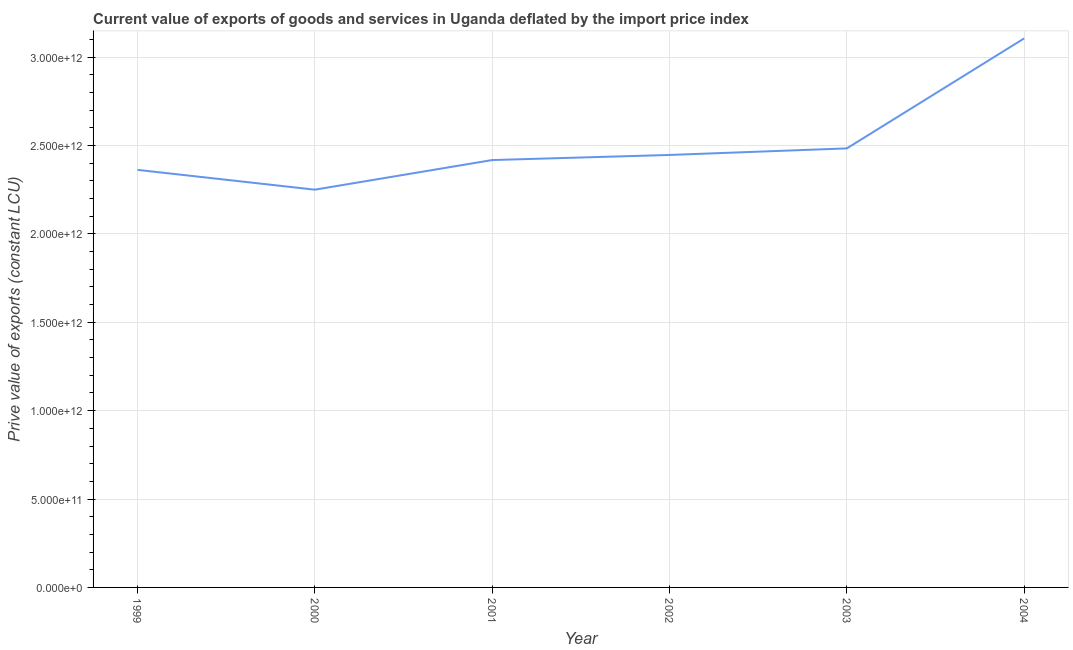What is the price value of exports in 2002?
Provide a short and direct response. 2.45e+12. Across all years, what is the maximum price value of exports?
Ensure brevity in your answer.  3.11e+12. Across all years, what is the minimum price value of exports?
Offer a terse response. 2.25e+12. In which year was the price value of exports maximum?
Your answer should be very brief. 2004. In which year was the price value of exports minimum?
Make the answer very short. 2000. What is the sum of the price value of exports?
Provide a short and direct response. 1.51e+13. What is the difference between the price value of exports in 2000 and 2001?
Offer a terse response. -1.68e+11. What is the average price value of exports per year?
Provide a succinct answer. 2.51e+12. What is the median price value of exports?
Your answer should be very brief. 2.43e+12. What is the ratio of the price value of exports in 1999 to that in 2002?
Your answer should be compact. 0.97. Is the difference between the price value of exports in 2002 and 2003 greater than the difference between any two years?
Your answer should be very brief. No. What is the difference between the highest and the second highest price value of exports?
Make the answer very short. 6.22e+11. Is the sum of the price value of exports in 1999 and 2000 greater than the maximum price value of exports across all years?
Your answer should be compact. Yes. What is the difference between the highest and the lowest price value of exports?
Make the answer very short. 8.56e+11. In how many years, is the price value of exports greater than the average price value of exports taken over all years?
Keep it short and to the point. 1. What is the difference between two consecutive major ticks on the Y-axis?
Provide a short and direct response. 5.00e+11. Does the graph contain grids?
Ensure brevity in your answer.  Yes. What is the title of the graph?
Provide a succinct answer. Current value of exports of goods and services in Uganda deflated by the import price index. What is the label or title of the X-axis?
Give a very brief answer. Year. What is the label or title of the Y-axis?
Your answer should be very brief. Prive value of exports (constant LCU). What is the Prive value of exports (constant LCU) of 1999?
Your answer should be very brief. 2.36e+12. What is the Prive value of exports (constant LCU) of 2000?
Provide a short and direct response. 2.25e+12. What is the Prive value of exports (constant LCU) of 2001?
Give a very brief answer. 2.42e+12. What is the Prive value of exports (constant LCU) of 2002?
Offer a terse response. 2.45e+12. What is the Prive value of exports (constant LCU) of 2003?
Your response must be concise. 2.48e+12. What is the Prive value of exports (constant LCU) of 2004?
Provide a succinct answer. 3.11e+12. What is the difference between the Prive value of exports (constant LCU) in 1999 and 2000?
Give a very brief answer. 1.12e+11. What is the difference between the Prive value of exports (constant LCU) in 1999 and 2001?
Your answer should be very brief. -5.55e+1. What is the difference between the Prive value of exports (constant LCU) in 1999 and 2002?
Give a very brief answer. -8.44e+1. What is the difference between the Prive value of exports (constant LCU) in 1999 and 2003?
Provide a succinct answer. -1.21e+11. What is the difference between the Prive value of exports (constant LCU) in 1999 and 2004?
Your answer should be compact. -7.44e+11. What is the difference between the Prive value of exports (constant LCU) in 2000 and 2001?
Offer a terse response. -1.68e+11. What is the difference between the Prive value of exports (constant LCU) in 2000 and 2002?
Keep it short and to the point. -1.96e+11. What is the difference between the Prive value of exports (constant LCU) in 2000 and 2003?
Provide a short and direct response. -2.34e+11. What is the difference between the Prive value of exports (constant LCU) in 2000 and 2004?
Offer a terse response. -8.56e+11. What is the difference between the Prive value of exports (constant LCU) in 2001 and 2002?
Provide a succinct answer. -2.89e+1. What is the difference between the Prive value of exports (constant LCU) in 2001 and 2003?
Make the answer very short. -6.60e+1. What is the difference between the Prive value of exports (constant LCU) in 2001 and 2004?
Your response must be concise. -6.88e+11. What is the difference between the Prive value of exports (constant LCU) in 2002 and 2003?
Your answer should be very brief. -3.71e+1. What is the difference between the Prive value of exports (constant LCU) in 2002 and 2004?
Give a very brief answer. -6.59e+11. What is the difference between the Prive value of exports (constant LCU) in 2003 and 2004?
Your response must be concise. -6.22e+11. What is the ratio of the Prive value of exports (constant LCU) in 1999 to that in 2000?
Your answer should be very brief. 1.05. What is the ratio of the Prive value of exports (constant LCU) in 1999 to that in 2001?
Keep it short and to the point. 0.98. What is the ratio of the Prive value of exports (constant LCU) in 1999 to that in 2002?
Give a very brief answer. 0.97. What is the ratio of the Prive value of exports (constant LCU) in 1999 to that in 2003?
Keep it short and to the point. 0.95. What is the ratio of the Prive value of exports (constant LCU) in 1999 to that in 2004?
Offer a very short reply. 0.76. What is the ratio of the Prive value of exports (constant LCU) in 2000 to that in 2001?
Your response must be concise. 0.93. What is the ratio of the Prive value of exports (constant LCU) in 2000 to that in 2002?
Make the answer very short. 0.92. What is the ratio of the Prive value of exports (constant LCU) in 2000 to that in 2003?
Make the answer very short. 0.91. What is the ratio of the Prive value of exports (constant LCU) in 2000 to that in 2004?
Your response must be concise. 0.72. What is the ratio of the Prive value of exports (constant LCU) in 2001 to that in 2003?
Provide a succinct answer. 0.97. What is the ratio of the Prive value of exports (constant LCU) in 2001 to that in 2004?
Your answer should be compact. 0.78. What is the ratio of the Prive value of exports (constant LCU) in 2002 to that in 2004?
Make the answer very short. 0.79. What is the ratio of the Prive value of exports (constant LCU) in 2003 to that in 2004?
Offer a very short reply. 0.8. 